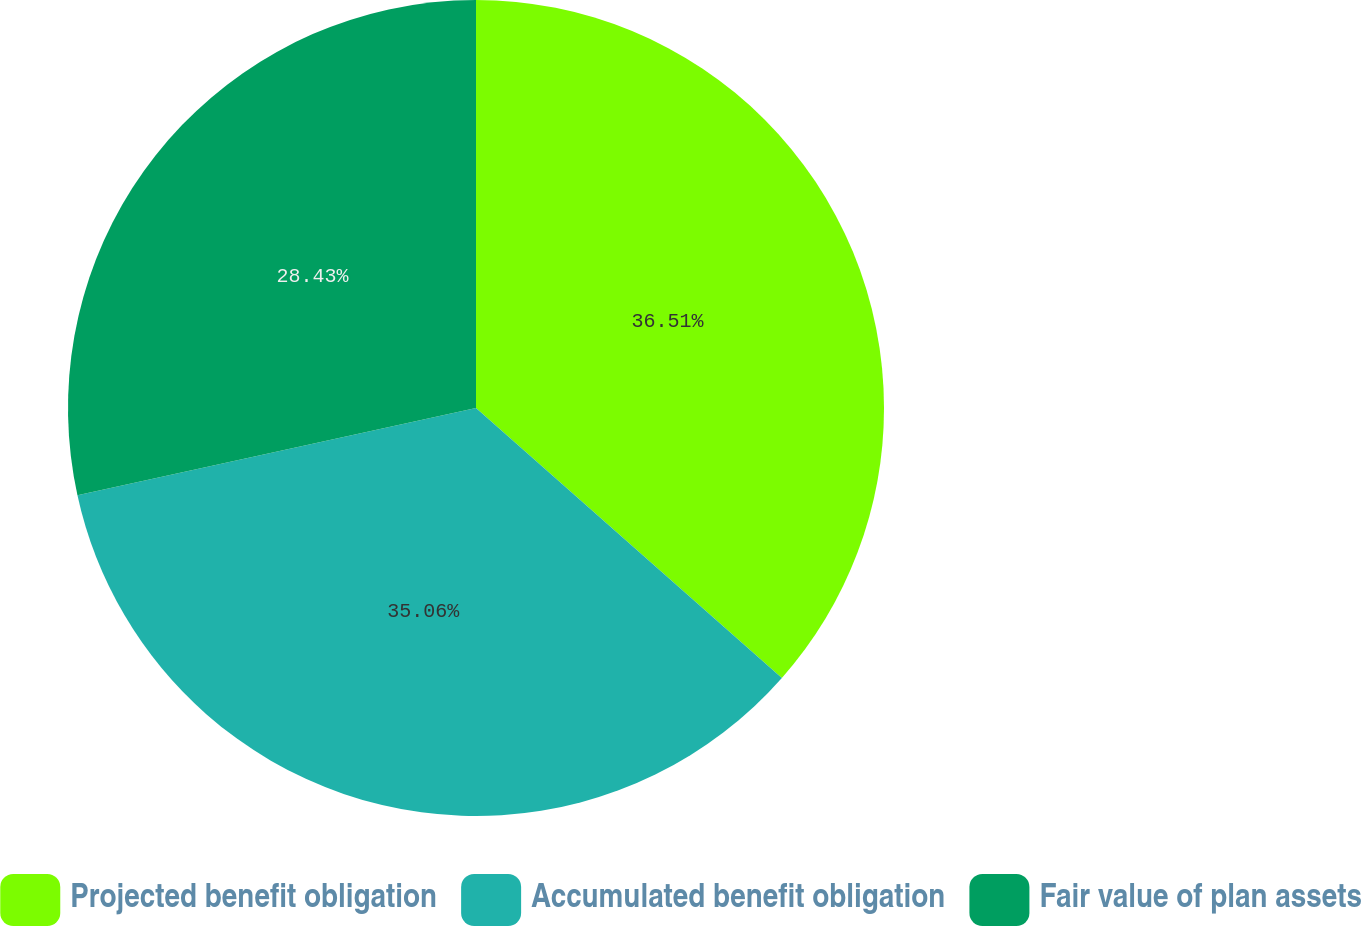<chart> <loc_0><loc_0><loc_500><loc_500><pie_chart><fcel>Projected benefit obligation<fcel>Accumulated benefit obligation<fcel>Fair value of plan assets<nl><fcel>36.51%<fcel>35.06%<fcel>28.43%<nl></chart> 